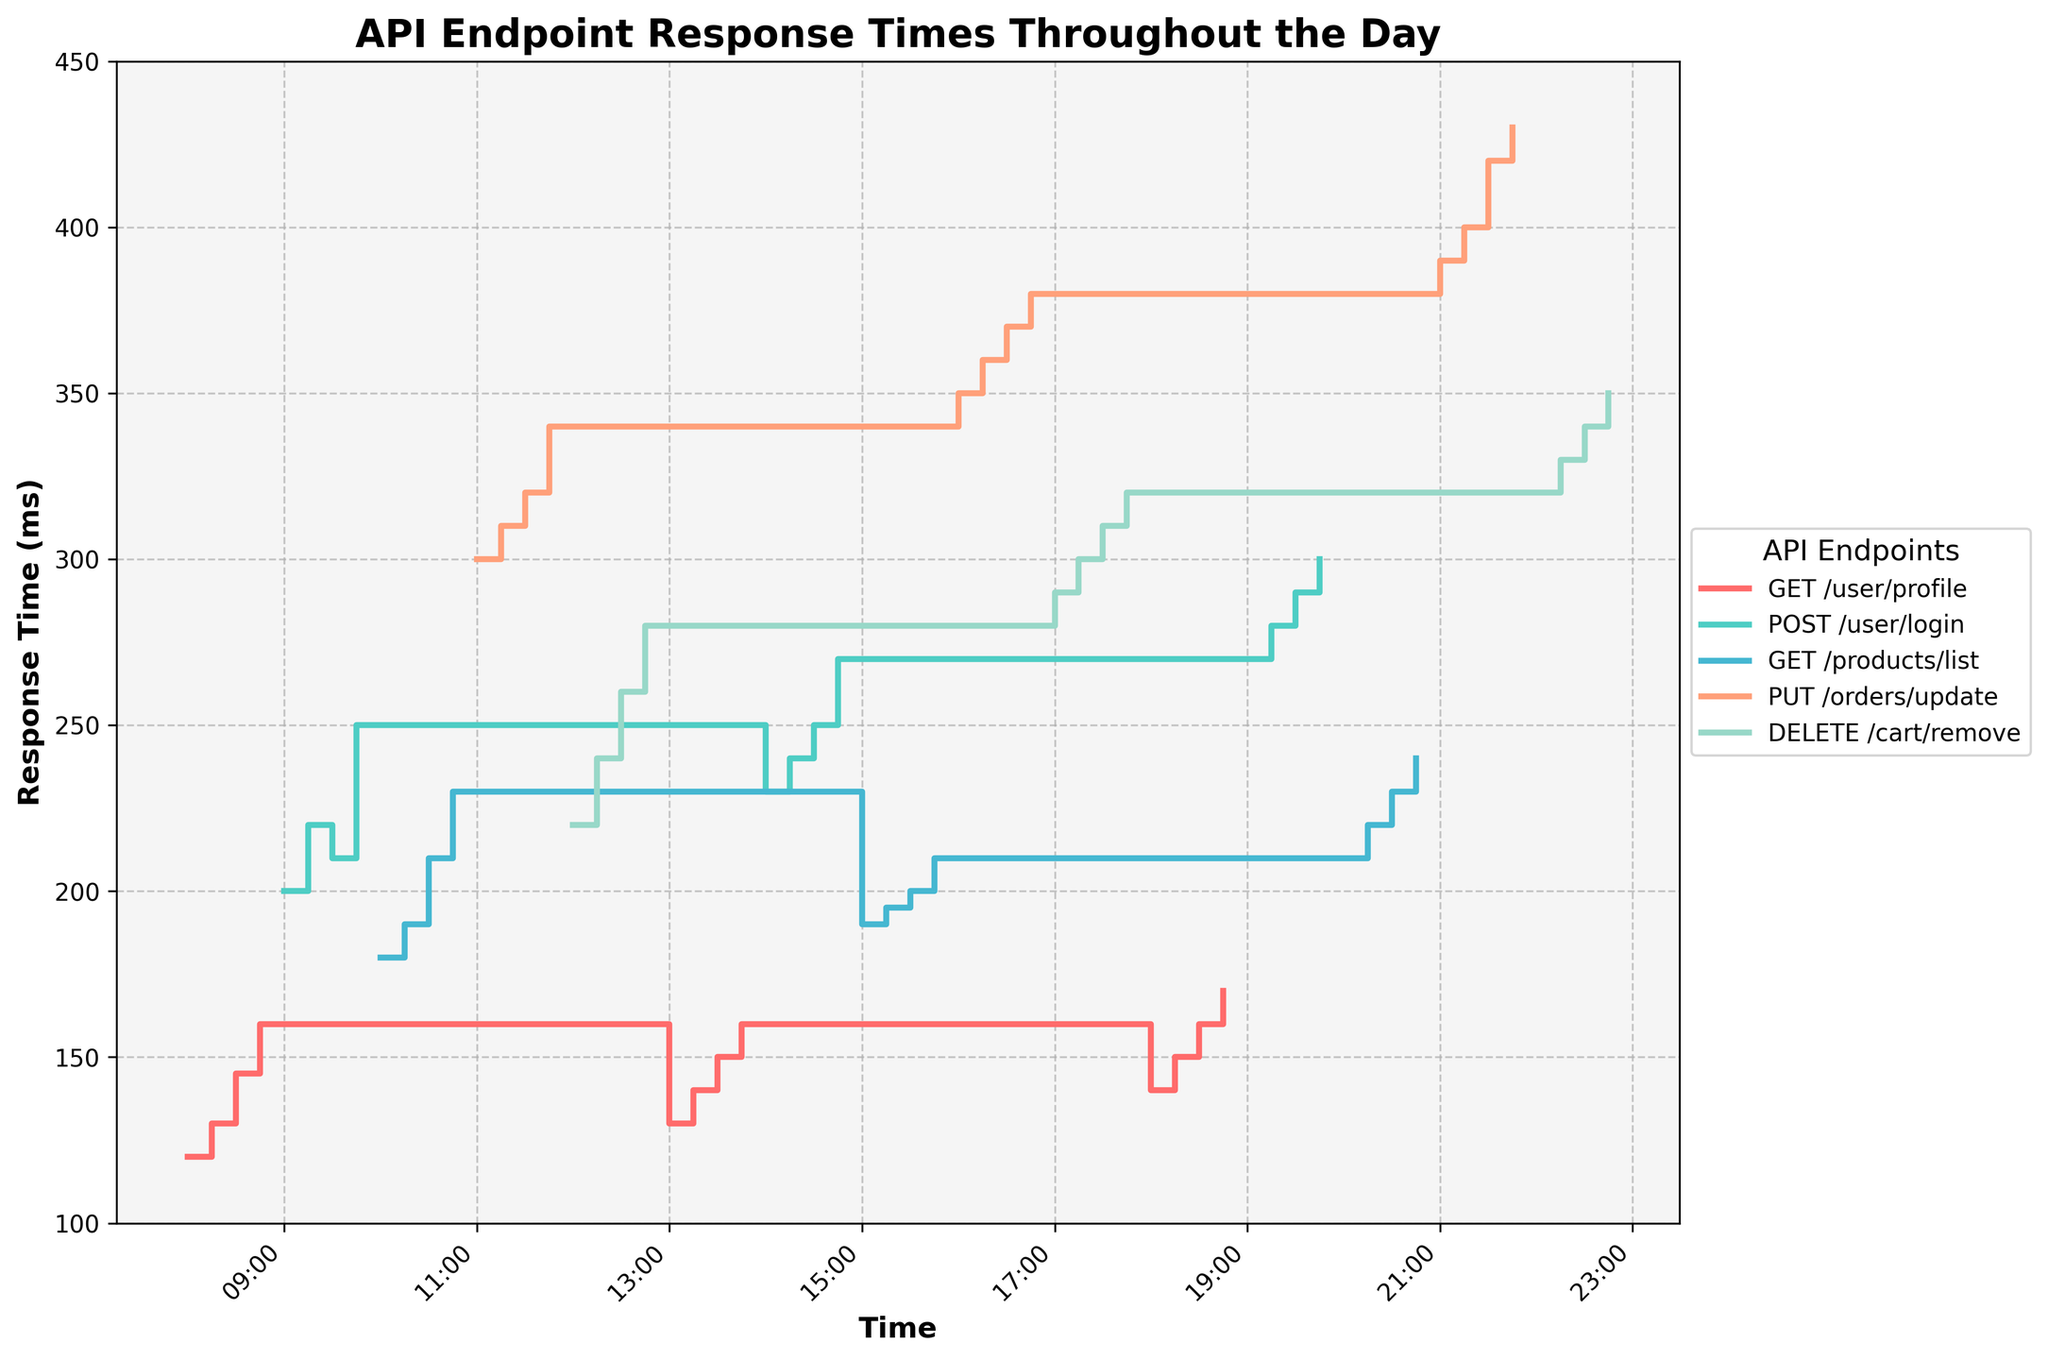What is the title of the figure? The title of the figure is displayed on top of the graph and indicates the content being visualized.
Answer: API Endpoint Response Times Throughout the Day Which API endpoint has the highest response time at 11:00? Looking at the x-axis for 11:00 and finding the highest point along the y-axis at this time, the PUT /orders/update endpoint is at the highest point.
Answer: PUT /orders/update How does the response time of GET /products/list at 10:00 compare to that at 15:00? Locate the response times for GET /products/list at 10:00 and 15:00 on the plot. At 10:00, the response time is 180ms, and at 15:00, it is 190ms.
Answer: The response time at 15:00 is higher What is the average response time for the DELETE /cart/remove endpoint? Locate all data points for DELETE /cart/remove, sum them up and divide by the number of points. The response times are (220 + 240 + 260 + 280 + 290 + 300 + 310 + 320 + 320 + 330 + 340 + 350) = 3760. Divide by 12 points.
Answer: 313.33 ms During which time period does the response time of POST /user/login exceed 250ms? Look for the time intervals on the x-axis where the POST /user/login response time line is above 250ms on the y-axis. It exceeds 250ms from 14:45 to 15:00 and from 18:45 to 20:00.
Answer: 14:45 - 15:00, 18:45 - 20:00 How many times does the response time of GET /user/profile reach 160ms? Count the number of times the GET /user/profile line touches 160ms on the y-axis. The data points at 08:45, 13:45, and 18:30 are at 160ms.
Answer: 3 times What is the difference in response times of PUT /orders/update between 16:00 and 21:00? Find the response time of PUT /orders/update at 16:00 (350ms) and at 21:00 (390ms). Subtract the earlier time’s response time from the later one: 390 - 350.
Answer: 40 ms Which API endpoint consistently shows the highest response times throughout the day? Examine which endpoint has the highest line position most frequently across different times. The PUT /orders/update endpoint has the highest response times through most of the day.
Answer: PUT /orders/update At what time does the DELETE /cart/remove response time first reach 300ms? Trace the DELETE /cart/remove line until it touches 300ms on the y-axis. This happens at 17:15.
Answer: 17:15 